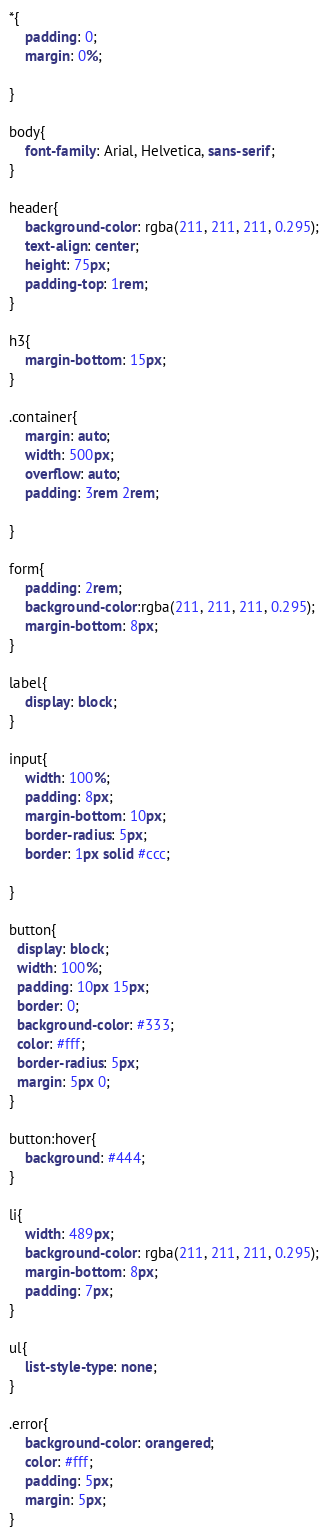Convert code to text. <code><loc_0><loc_0><loc_500><loc_500><_CSS_>*{
    padding: 0;
    margin: 0%;

}

body{
    font-family: Arial, Helvetica, sans-serif;
}

header{
    background-color: rgba(211, 211, 211, 0.295);
    text-align: center;
    height: 75px;
    padding-top: 1rem;
}

h3{
    margin-bottom: 15px;
}

.container{
    margin: auto;
    width: 500px;
    overflow: auto;
    padding: 3rem 2rem;
    
}

form{
    padding: 2rem;
    background-color:rgba(211, 211, 211, 0.295);
    margin-bottom: 8px;
}

label{
    display: block;
}

input{
    width: 100%;
    padding: 8px;
    margin-bottom: 10px;
    border-radius: 5px;
    border: 1px solid #ccc;
    
}

button{
  display: block;
  width: 100%;
  padding: 10px 15px;
  border: 0;
  background-color: #333;
  color: #fff;
  border-radius: 5px;
  margin: 5px 0;
}

button:hover{
    background: #444;
}

li{
    width: 489px;
    background-color: rgba(211, 211, 211, 0.295);
    margin-bottom: 8px;
    padding: 7px;
}

ul{
    list-style-type: none;
}

.error{
    background-color: orangered;
    color: #fff;
    padding: 5px;
    margin: 5px;
}</code> 